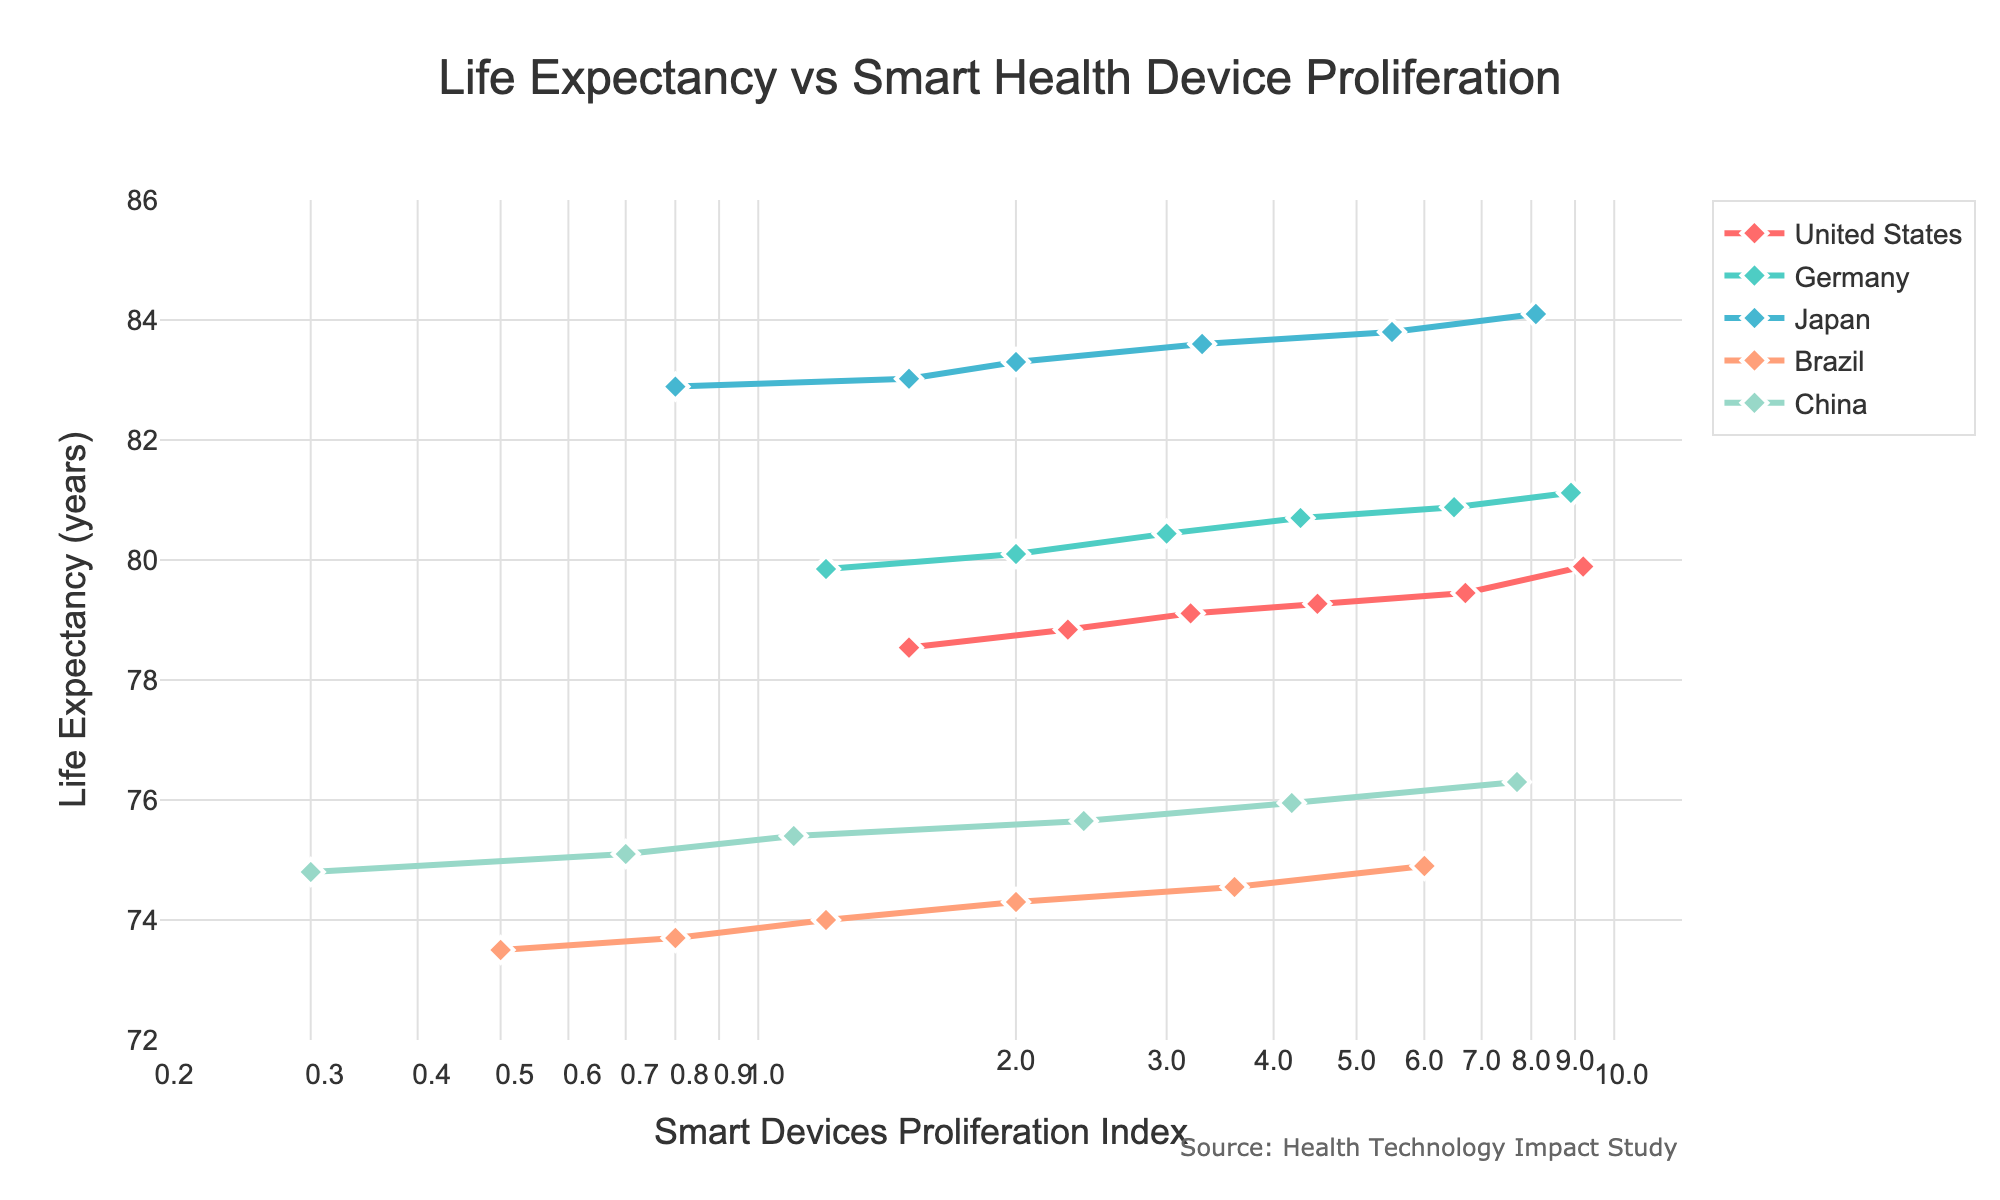What is the title of the figure? The title is shown at the top of the figure in larger font size. It reads "Life Expectancy vs Smart Health Device Proliferation".
Answer: Life Expectancy vs Smart Health Device Proliferation Which country had the highest life expectancy in 2010? Evaluating the y-axis values for the year 2010 and comparing the points for each country, Japan is highest around 82.9 years.
Answer: Japan In which year did China have a Smart Devices Proliferation Index of 2.4? By locating China's data line and looking for the point where the x-axis is 2.4 in log scale, the year label indicates 2016.
Answer: 2016 What was the Life Expectancy of Brazil in 2020? By following Brazil's line to the year 2020 and checking its y-axis position, the life expectancy is approximately 74.9 years.
Answer: 74.9 years Compare the growth in life expectancy between Germany and the United States from 2010 to 2020. Which country had a greater improvement? By evaluating the endpoint differences on their respective y-axis values, Germany's life expectancy grew from 79.85 to 81.12 (1.27 years) while the US grew from 78.54 to 79.89 (1.35 years). Thus, the US had a greater improvement.
Answer: United States Does Japan's life expectancy show a proportional increase with the Smart Devices Proliferation Index? From the figure, observing Japan’s life expectancy pathway shows gradual increases, correlating well with the rise in the index, indicating proportionality.
Answer: Yes What is the general trend in life expectancy for all countries as the Smart Devices Proliferation Index increases? Observing all the lines, there is a noticeable upward trend for life expectancy as the Smart Devices Proliferation Index increases, showing positive correlation.
Answer: Increase Compare the overall slopes of the trend lines for Germany and Brazil. Which country has a steeper increase? Visually assessing the slopes of both lines, Germany's line is steeper in its upward trend compared to Brazil, indicating a faster rate of life expectancy improvement.
Answer: Germany What is the approximate range of the Smart Devices Proliferation Index shown on the x-axis? The x-axis starts from around 0.2 and extends to approximately 12, noted in a logarithmic scale.
Answer: 0.2 to 12 Which country had the smallest increase in the Smart Devices Proliferation Index from 2010 to 2020? Observing changes in the x-axis for each country's data points from 2010 to 2020, Japan shows the smallest increase from 0.8 to 8.1 (a change of 7.3).
Answer: Japan 